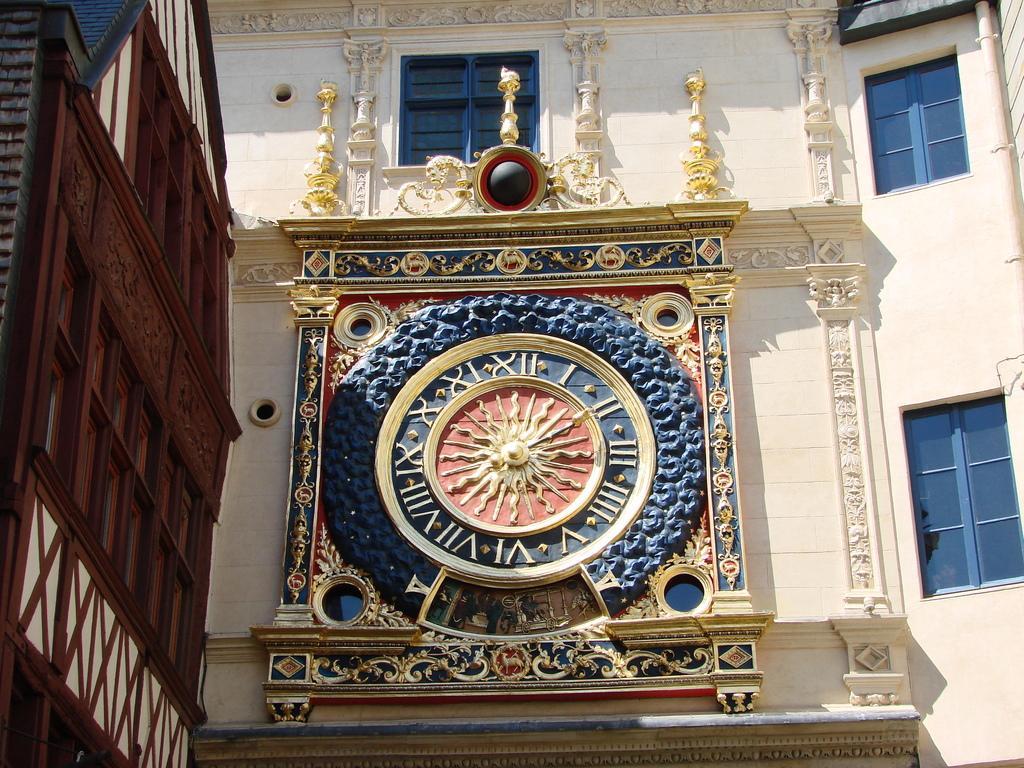Can you describe this image briefly? In this image I can see few walls and in the centre of the image I can see a clock on the wall. I can also see few windows. 